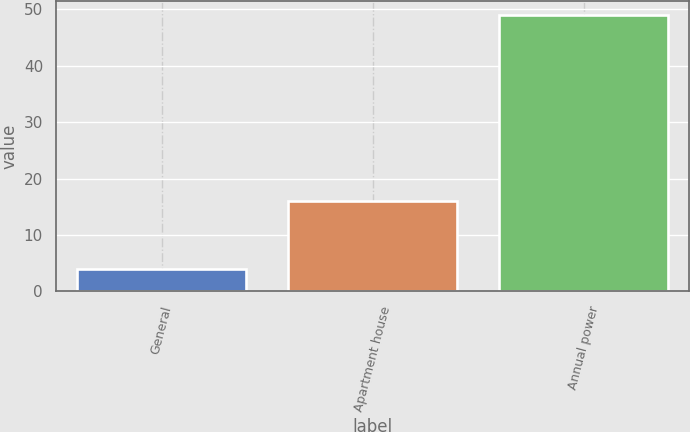Convert chart to OTSL. <chart><loc_0><loc_0><loc_500><loc_500><bar_chart><fcel>General<fcel>Apartment house<fcel>Annual power<nl><fcel>4<fcel>16<fcel>49<nl></chart> 